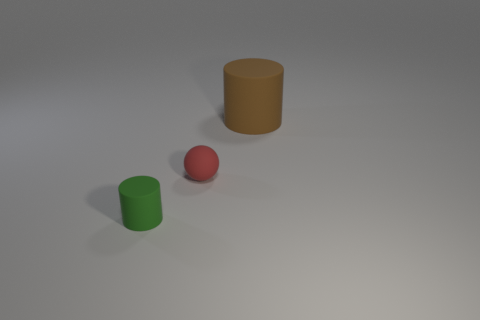Do the brown object behind the tiny green cylinder and the small matte object that is to the left of the red rubber ball have the same shape?
Ensure brevity in your answer.  Yes. There is a matte object that is to the left of the brown rubber cylinder and right of the small green matte object; how big is it?
Offer a very short reply. Small. How many other things are the same color as the small cylinder?
Give a very brief answer. 0. Are the tiny thing behind the small green rubber thing and the big brown thing made of the same material?
Make the answer very short. Yes. Is there anything else that has the same size as the sphere?
Your response must be concise. Yes. Are there fewer red matte things that are on the right side of the big brown object than small spheres right of the matte sphere?
Provide a short and direct response. No. Is there anything else that is the same shape as the tiny green object?
Offer a terse response. Yes. How many small matte things are on the right side of the tiny matte object on the right side of the small matte object that is in front of the small red sphere?
Give a very brief answer. 0. There is a large cylinder; how many objects are left of it?
Keep it short and to the point. 2. How many big brown balls have the same material as the small green cylinder?
Provide a succinct answer. 0. 